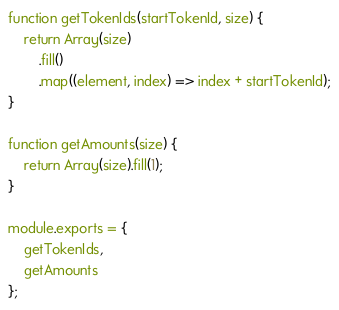Convert code to text. <code><loc_0><loc_0><loc_500><loc_500><_JavaScript_>function getTokenIds(startTokenId, size) {
    return Array(size)
        .fill()
        .map((element, index) => index + startTokenId);
}

function getAmounts(size) {
    return Array(size).fill(1);
}

module.exports = {
    getTokenIds,
    getAmounts
};
</code> 